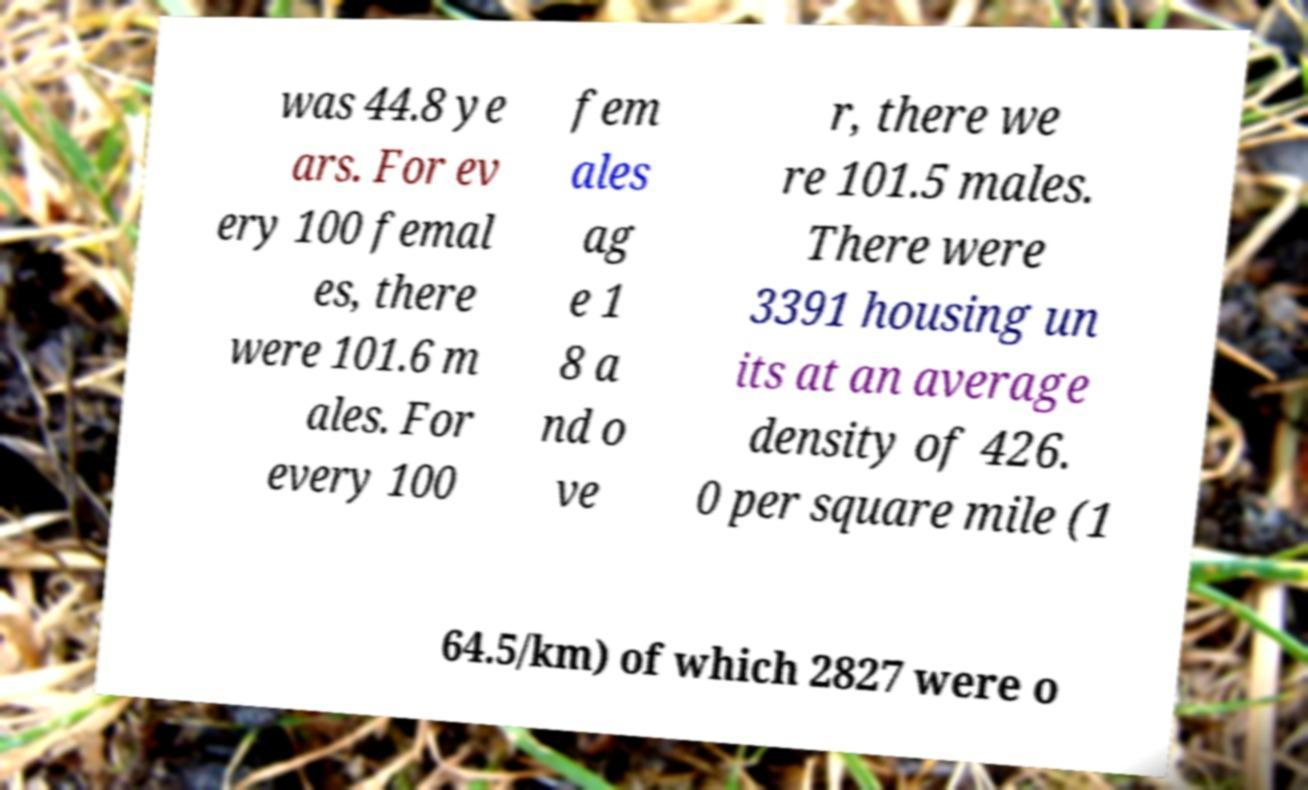I need the written content from this picture converted into text. Can you do that? was 44.8 ye ars. For ev ery 100 femal es, there were 101.6 m ales. For every 100 fem ales ag e 1 8 a nd o ve r, there we re 101.5 males. There were 3391 housing un its at an average density of 426. 0 per square mile (1 64.5/km) of which 2827 were o 